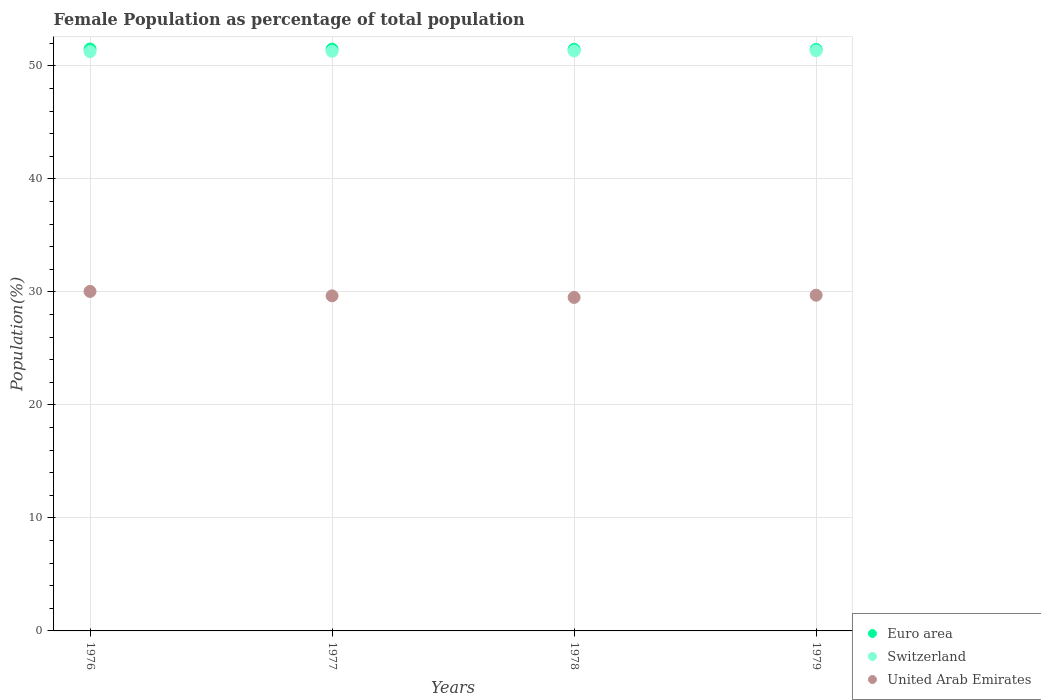How many different coloured dotlines are there?
Your response must be concise. 3. What is the female population in in United Arab Emirates in 1979?
Provide a short and direct response. 29.71. Across all years, what is the maximum female population in in Switzerland?
Provide a succinct answer. 51.34. Across all years, what is the minimum female population in in Euro area?
Your response must be concise. 51.46. In which year was the female population in in Switzerland maximum?
Provide a succinct answer. 1979. In which year was the female population in in Euro area minimum?
Your answer should be very brief. 1979. What is the total female population in in Euro area in the graph?
Your answer should be compact. 205.91. What is the difference between the female population in in United Arab Emirates in 1977 and that in 1978?
Keep it short and to the point. 0.14. What is the difference between the female population in in United Arab Emirates in 1979 and the female population in in Switzerland in 1978?
Your answer should be very brief. -21.61. What is the average female population in in Switzerland per year?
Make the answer very short. 51.31. In the year 1977, what is the difference between the female population in in United Arab Emirates and female population in in Euro area?
Make the answer very short. -21.83. In how many years, is the female population in in Euro area greater than 34 %?
Offer a very short reply. 4. What is the ratio of the female population in in Switzerland in 1978 to that in 1979?
Make the answer very short. 1. Is the difference between the female population in in United Arab Emirates in 1976 and 1977 greater than the difference between the female population in in Euro area in 1976 and 1977?
Your answer should be compact. Yes. What is the difference between the highest and the second highest female population in in United Arab Emirates?
Offer a very short reply. 0.33. What is the difference between the highest and the lowest female population in in Switzerland?
Your answer should be compact. 0.08. In how many years, is the female population in in Euro area greater than the average female population in in Euro area taken over all years?
Your response must be concise. 2. Does the female population in in Switzerland monotonically increase over the years?
Your response must be concise. Yes. Is the female population in in United Arab Emirates strictly greater than the female population in in Switzerland over the years?
Make the answer very short. No. Is the female population in in Euro area strictly less than the female population in in United Arab Emirates over the years?
Give a very brief answer. No. How many dotlines are there?
Your response must be concise. 3. How many years are there in the graph?
Give a very brief answer. 4. Are the values on the major ticks of Y-axis written in scientific E-notation?
Provide a succinct answer. No. How are the legend labels stacked?
Offer a terse response. Vertical. What is the title of the graph?
Your answer should be very brief. Female Population as percentage of total population. Does "Albania" appear as one of the legend labels in the graph?
Keep it short and to the point. No. What is the label or title of the X-axis?
Your answer should be compact. Years. What is the label or title of the Y-axis?
Ensure brevity in your answer.  Population(%). What is the Population(%) of Euro area in 1976?
Your answer should be very brief. 51.5. What is the Population(%) in Switzerland in 1976?
Keep it short and to the point. 51.26. What is the Population(%) in United Arab Emirates in 1976?
Your answer should be compact. 30.04. What is the Population(%) of Euro area in 1977?
Your response must be concise. 51.48. What is the Population(%) in Switzerland in 1977?
Your answer should be very brief. 51.3. What is the Population(%) in United Arab Emirates in 1977?
Provide a short and direct response. 29.65. What is the Population(%) in Euro area in 1978?
Provide a succinct answer. 51.47. What is the Population(%) in Switzerland in 1978?
Your answer should be compact. 51.32. What is the Population(%) of United Arab Emirates in 1978?
Keep it short and to the point. 29.51. What is the Population(%) in Euro area in 1979?
Give a very brief answer. 51.46. What is the Population(%) of Switzerland in 1979?
Your response must be concise. 51.34. What is the Population(%) in United Arab Emirates in 1979?
Your response must be concise. 29.71. Across all years, what is the maximum Population(%) of Euro area?
Make the answer very short. 51.5. Across all years, what is the maximum Population(%) of Switzerland?
Provide a short and direct response. 51.34. Across all years, what is the maximum Population(%) of United Arab Emirates?
Give a very brief answer. 30.04. Across all years, what is the minimum Population(%) of Euro area?
Offer a very short reply. 51.46. Across all years, what is the minimum Population(%) of Switzerland?
Provide a short and direct response. 51.26. Across all years, what is the minimum Population(%) of United Arab Emirates?
Offer a terse response. 29.51. What is the total Population(%) of Euro area in the graph?
Your response must be concise. 205.91. What is the total Population(%) in Switzerland in the graph?
Make the answer very short. 205.23. What is the total Population(%) of United Arab Emirates in the graph?
Ensure brevity in your answer.  118.91. What is the difference between the Population(%) of Euro area in 1976 and that in 1977?
Give a very brief answer. 0.01. What is the difference between the Population(%) of Switzerland in 1976 and that in 1977?
Ensure brevity in your answer.  -0.03. What is the difference between the Population(%) in United Arab Emirates in 1976 and that in 1977?
Ensure brevity in your answer.  0.39. What is the difference between the Population(%) in Euro area in 1976 and that in 1978?
Provide a short and direct response. 0.03. What is the difference between the Population(%) of Switzerland in 1976 and that in 1978?
Make the answer very short. -0.06. What is the difference between the Population(%) in United Arab Emirates in 1976 and that in 1978?
Keep it short and to the point. 0.53. What is the difference between the Population(%) of Euro area in 1976 and that in 1979?
Offer a very short reply. 0.04. What is the difference between the Population(%) in Switzerland in 1976 and that in 1979?
Give a very brief answer. -0.08. What is the difference between the Population(%) of United Arab Emirates in 1976 and that in 1979?
Offer a very short reply. 0.33. What is the difference between the Population(%) in Euro area in 1977 and that in 1978?
Provide a succinct answer. 0.01. What is the difference between the Population(%) in Switzerland in 1977 and that in 1978?
Your answer should be very brief. -0.03. What is the difference between the Population(%) of United Arab Emirates in 1977 and that in 1978?
Make the answer very short. 0.14. What is the difference between the Population(%) in Euro area in 1977 and that in 1979?
Your answer should be very brief. 0.02. What is the difference between the Population(%) in Switzerland in 1977 and that in 1979?
Offer a terse response. -0.05. What is the difference between the Population(%) of United Arab Emirates in 1977 and that in 1979?
Your answer should be very brief. -0.06. What is the difference between the Population(%) in Euro area in 1978 and that in 1979?
Make the answer very short. 0.01. What is the difference between the Population(%) in Switzerland in 1978 and that in 1979?
Keep it short and to the point. -0.02. What is the difference between the Population(%) in United Arab Emirates in 1978 and that in 1979?
Make the answer very short. -0.2. What is the difference between the Population(%) in Euro area in 1976 and the Population(%) in Switzerland in 1977?
Offer a terse response. 0.2. What is the difference between the Population(%) in Euro area in 1976 and the Population(%) in United Arab Emirates in 1977?
Provide a short and direct response. 21.84. What is the difference between the Population(%) in Switzerland in 1976 and the Population(%) in United Arab Emirates in 1977?
Offer a very short reply. 21.61. What is the difference between the Population(%) in Euro area in 1976 and the Population(%) in Switzerland in 1978?
Make the answer very short. 0.17. What is the difference between the Population(%) of Euro area in 1976 and the Population(%) of United Arab Emirates in 1978?
Provide a short and direct response. 21.98. What is the difference between the Population(%) of Switzerland in 1976 and the Population(%) of United Arab Emirates in 1978?
Your response must be concise. 21.75. What is the difference between the Population(%) of Euro area in 1976 and the Population(%) of Switzerland in 1979?
Ensure brevity in your answer.  0.15. What is the difference between the Population(%) of Euro area in 1976 and the Population(%) of United Arab Emirates in 1979?
Offer a very short reply. 21.79. What is the difference between the Population(%) in Switzerland in 1976 and the Population(%) in United Arab Emirates in 1979?
Offer a terse response. 21.56. What is the difference between the Population(%) of Euro area in 1977 and the Population(%) of Switzerland in 1978?
Offer a terse response. 0.16. What is the difference between the Population(%) of Euro area in 1977 and the Population(%) of United Arab Emirates in 1978?
Give a very brief answer. 21.97. What is the difference between the Population(%) of Switzerland in 1977 and the Population(%) of United Arab Emirates in 1978?
Provide a succinct answer. 21.78. What is the difference between the Population(%) of Euro area in 1977 and the Population(%) of Switzerland in 1979?
Provide a short and direct response. 0.14. What is the difference between the Population(%) of Euro area in 1977 and the Population(%) of United Arab Emirates in 1979?
Offer a terse response. 21.77. What is the difference between the Population(%) in Switzerland in 1977 and the Population(%) in United Arab Emirates in 1979?
Your answer should be compact. 21.59. What is the difference between the Population(%) in Euro area in 1978 and the Population(%) in Switzerland in 1979?
Give a very brief answer. 0.12. What is the difference between the Population(%) in Euro area in 1978 and the Population(%) in United Arab Emirates in 1979?
Make the answer very short. 21.76. What is the difference between the Population(%) in Switzerland in 1978 and the Population(%) in United Arab Emirates in 1979?
Your answer should be very brief. 21.61. What is the average Population(%) in Euro area per year?
Give a very brief answer. 51.48. What is the average Population(%) in Switzerland per year?
Provide a succinct answer. 51.31. What is the average Population(%) of United Arab Emirates per year?
Your answer should be very brief. 29.73. In the year 1976, what is the difference between the Population(%) of Euro area and Population(%) of Switzerland?
Provide a short and direct response. 0.23. In the year 1976, what is the difference between the Population(%) of Euro area and Population(%) of United Arab Emirates?
Make the answer very short. 21.45. In the year 1976, what is the difference between the Population(%) in Switzerland and Population(%) in United Arab Emirates?
Ensure brevity in your answer.  21.22. In the year 1977, what is the difference between the Population(%) of Euro area and Population(%) of Switzerland?
Your answer should be compact. 0.19. In the year 1977, what is the difference between the Population(%) in Euro area and Population(%) in United Arab Emirates?
Your answer should be very brief. 21.83. In the year 1977, what is the difference between the Population(%) in Switzerland and Population(%) in United Arab Emirates?
Give a very brief answer. 21.64. In the year 1978, what is the difference between the Population(%) in Euro area and Population(%) in Switzerland?
Ensure brevity in your answer.  0.15. In the year 1978, what is the difference between the Population(%) in Euro area and Population(%) in United Arab Emirates?
Your answer should be very brief. 21.96. In the year 1978, what is the difference between the Population(%) of Switzerland and Population(%) of United Arab Emirates?
Your response must be concise. 21.81. In the year 1979, what is the difference between the Population(%) of Euro area and Population(%) of Switzerland?
Your answer should be very brief. 0.12. In the year 1979, what is the difference between the Population(%) of Euro area and Population(%) of United Arab Emirates?
Provide a succinct answer. 21.75. In the year 1979, what is the difference between the Population(%) of Switzerland and Population(%) of United Arab Emirates?
Keep it short and to the point. 21.64. What is the ratio of the Population(%) of Euro area in 1976 to that in 1977?
Your response must be concise. 1. What is the ratio of the Population(%) of United Arab Emirates in 1976 to that in 1977?
Your answer should be compact. 1.01. What is the ratio of the Population(%) of United Arab Emirates in 1976 to that in 1978?
Provide a succinct answer. 1.02. What is the ratio of the Population(%) in Euro area in 1976 to that in 1979?
Keep it short and to the point. 1. What is the ratio of the Population(%) in Switzerland in 1976 to that in 1979?
Offer a terse response. 1. What is the ratio of the Population(%) of United Arab Emirates in 1976 to that in 1979?
Provide a succinct answer. 1.01. What is the ratio of the Population(%) in Euro area in 1977 to that in 1978?
Ensure brevity in your answer.  1. What is the ratio of the Population(%) in United Arab Emirates in 1977 to that in 1978?
Provide a succinct answer. 1. What is the ratio of the Population(%) of United Arab Emirates in 1977 to that in 1979?
Your response must be concise. 1. What is the ratio of the Population(%) of Euro area in 1978 to that in 1979?
Offer a very short reply. 1. What is the difference between the highest and the second highest Population(%) in Euro area?
Keep it short and to the point. 0.01. What is the difference between the highest and the second highest Population(%) in Switzerland?
Your answer should be very brief. 0.02. What is the difference between the highest and the second highest Population(%) in United Arab Emirates?
Offer a terse response. 0.33. What is the difference between the highest and the lowest Population(%) in Euro area?
Offer a very short reply. 0.04. What is the difference between the highest and the lowest Population(%) of Switzerland?
Keep it short and to the point. 0.08. What is the difference between the highest and the lowest Population(%) of United Arab Emirates?
Provide a short and direct response. 0.53. 